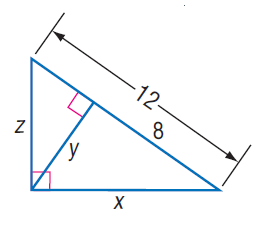Answer the mathemtical geometry problem and directly provide the correct option letter.
Question: Find x.
Choices: A: \sqrt { 6 } B: \sqrt { 6 } C: 4 D: 4 \sqrt { 6 } D 